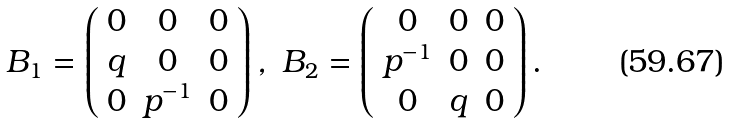<formula> <loc_0><loc_0><loc_500><loc_500>B _ { 1 } = \left ( \begin{array} { c c c } 0 & 0 & 0 \\ q & 0 & 0 \\ 0 & p ^ { - 1 } & 0 \end{array} \right ) , \ B _ { 2 } = \left ( \begin{array} { c c c } 0 & 0 & 0 \\ p ^ { - 1 } & 0 & 0 \\ 0 & q & 0 \end{array} \right ) .</formula> 